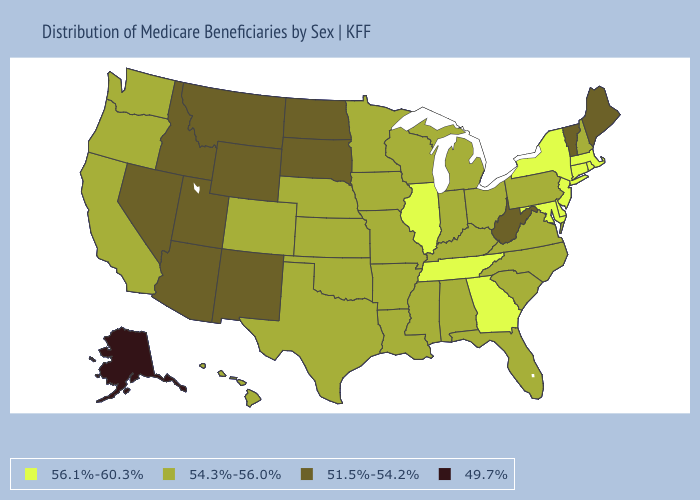Among the states that border New York , which have the highest value?
Answer briefly. Connecticut, Massachusetts, New Jersey. Does Hawaii have a higher value than Ohio?
Quick response, please. No. Among the states that border Montana , which have the lowest value?
Answer briefly. Idaho, North Dakota, South Dakota, Wyoming. Is the legend a continuous bar?
Give a very brief answer. No. Does Vermont have a higher value than Alaska?
Concise answer only. Yes. What is the highest value in the South ?
Concise answer only. 56.1%-60.3%. Which states hav the highest value in the West?
Give a very brief answer. California, Colorado, Hawaii, Oregon, Washington. Name the states that have a value in the range 49.7%?
Concise answer only. Alaska. What is the value of Massachusetts?
Answer briefly. 56.1%-60.3%. Name the states that have a value in the range 54.3%-56.0%?
Quick response, please. Alabama, Arkansas, California, Colorado, Florida, Hawaii, Indiana, Iowa, Kansas, Kentucky, Louisiana, Michigan, Minnesota, Mississippi, Missouri, Nebraska, New Hampshire, North Carolina, Ohio, Oklahoma, Oregon, Pennsylvania, South Carolina, Texas, Virginia, Washington, Wisconsin. What is the value of Minnesota?
Concise answer only. 54.3%-56.0%. Does Alaska have the lowest value in the USA?
Write a very short answer. Yes. What is the highest value in the USA?
Quick response, please. 56.1%-60.3%. Name the states that have a value in the range 56.1%-60.3%?
Give a very brief answer. Connecticut, Delaware, Georgia, Illinois, Maryland, Massachusetts, New Jersey, New York, Rhode Island, Tennessee. What is the value of Wisconsin?
Be succinct. 54.3%-56.0%. 